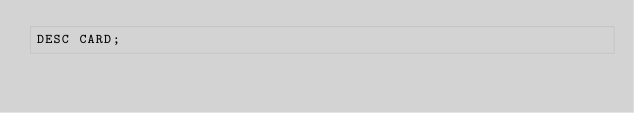Convert code to text. <code><loc_0><loc_0><loc_500><loc_500><_SQL_>DESC CARD;</code> 